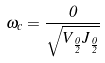Convert formula to latex. <formula><loc_0><loc_0><loc_500><loc_500>\omega _ { c } = \frac { 0 } { \sqrt { V _ { \frac { 0 } { 2 } } J _ { \frac { 0 } { 2 } } } }</formula> 